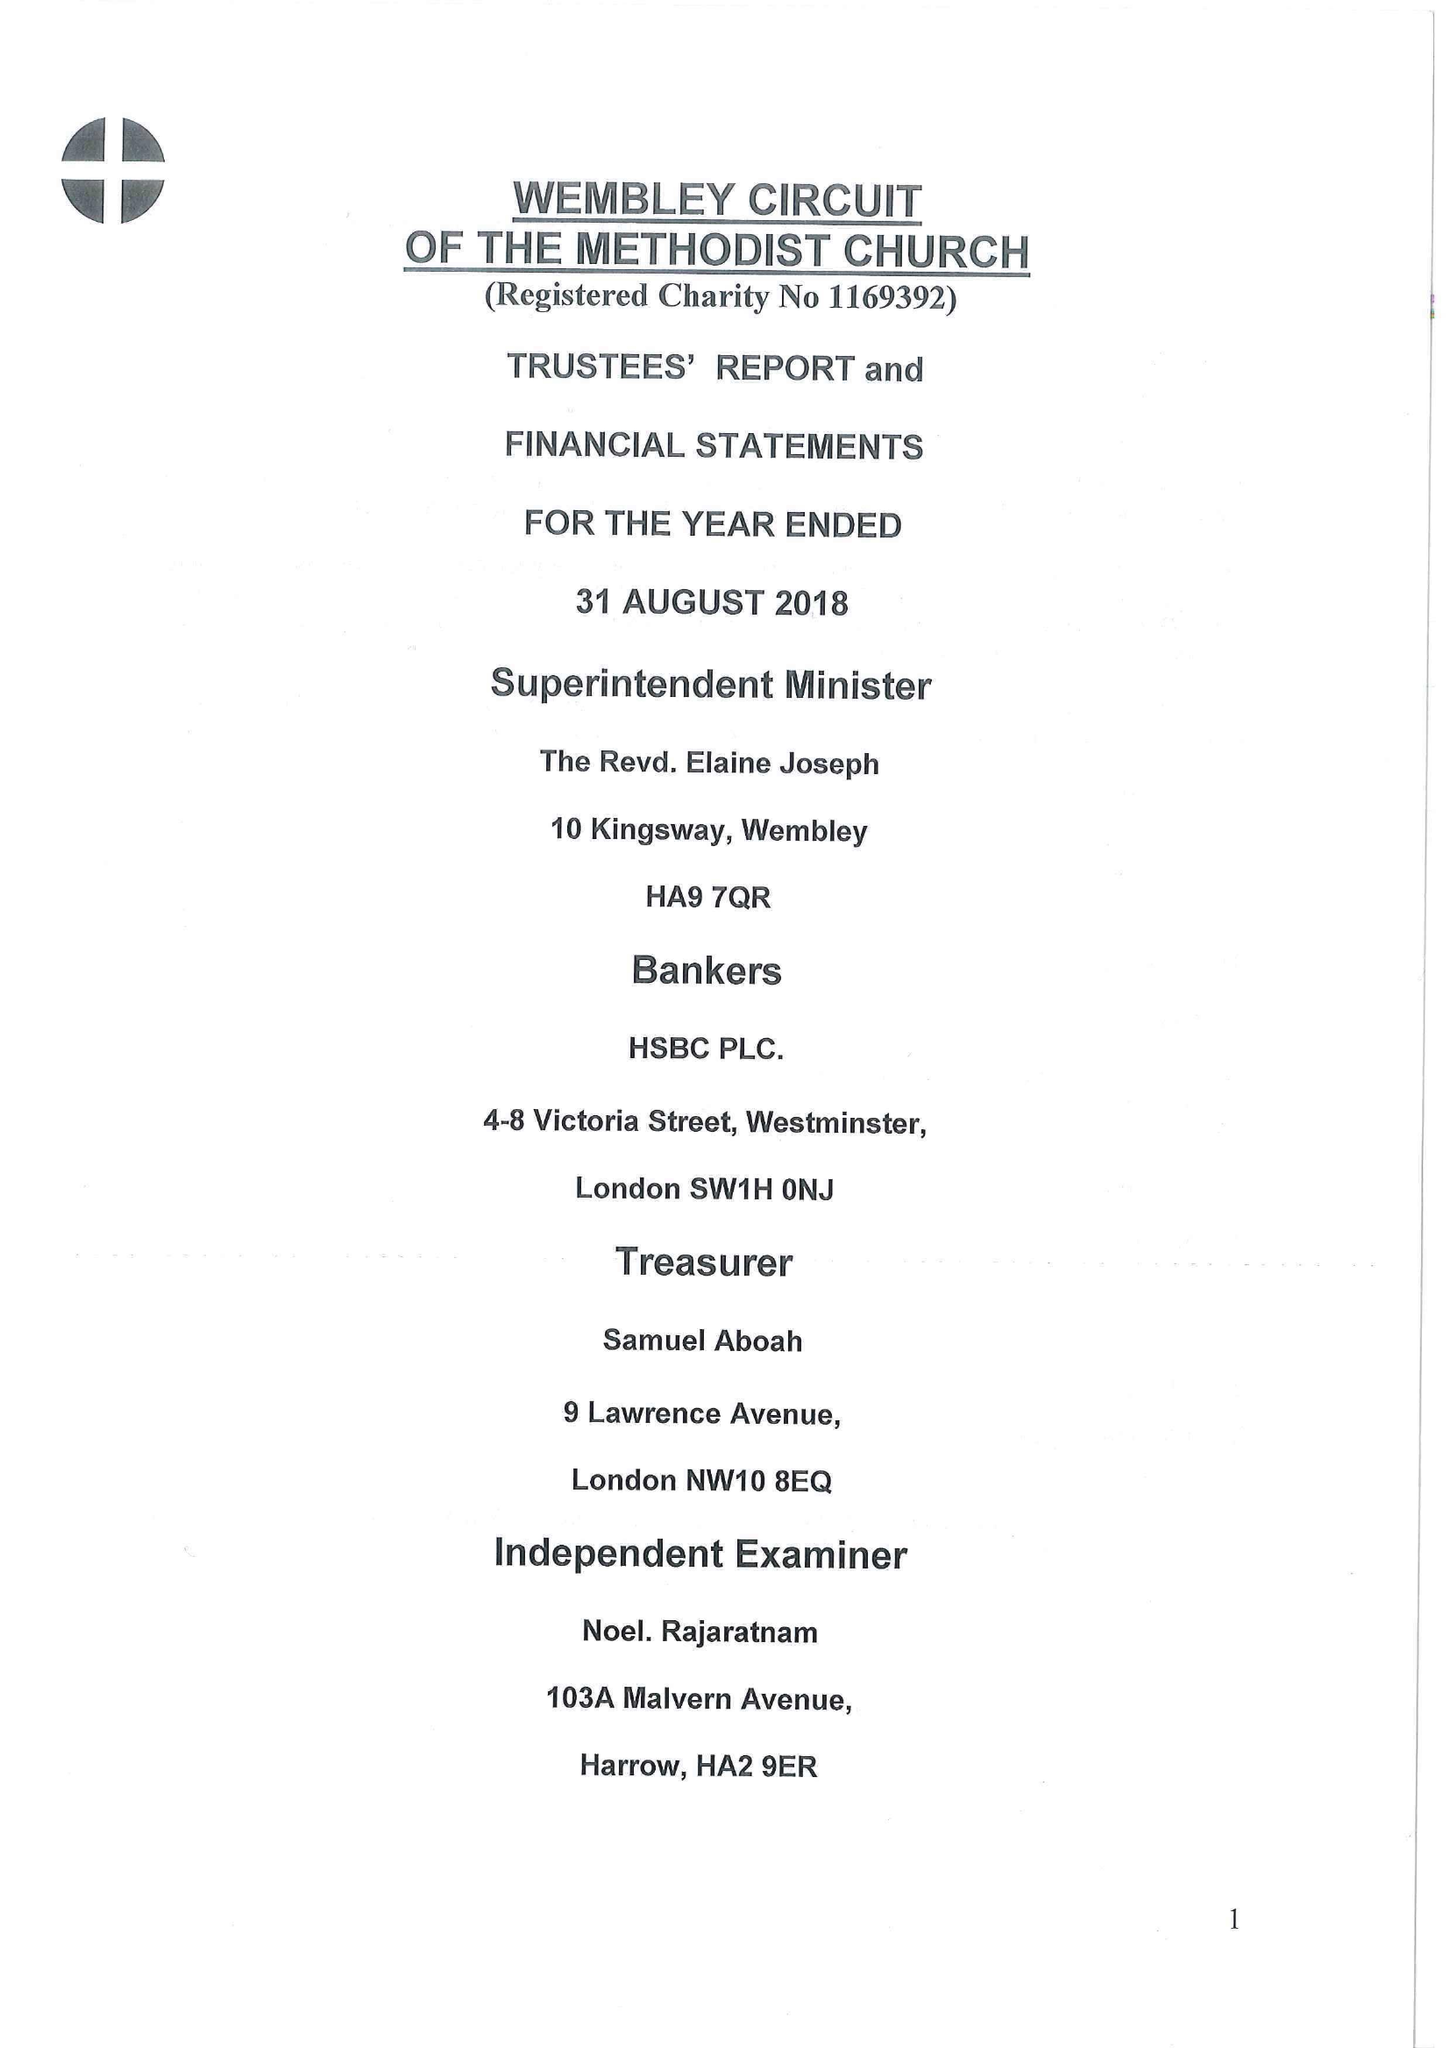What is the value for the address__street_line?
Answer the question using a single word or phrase. 10 KINGSWAY 